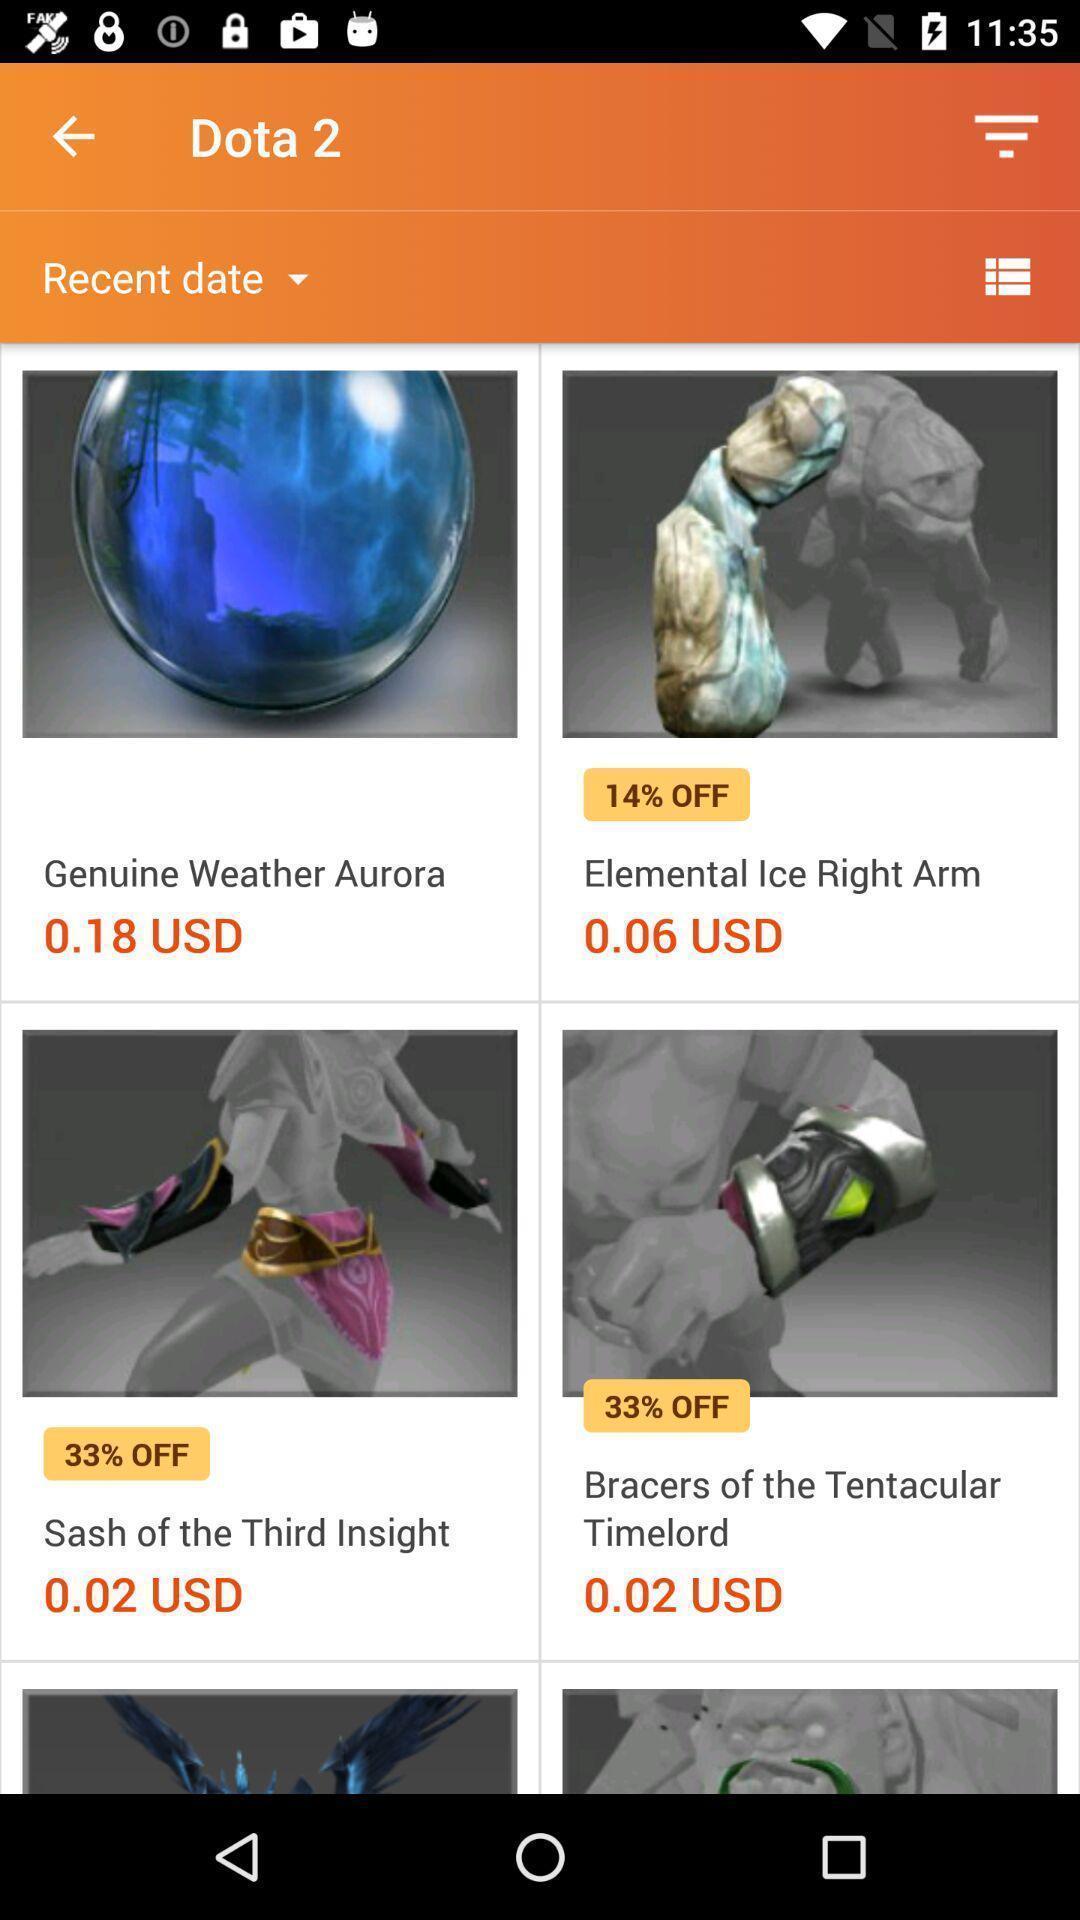Tell me about the visual elements in this screen capture. Page showing products from shopping app. 